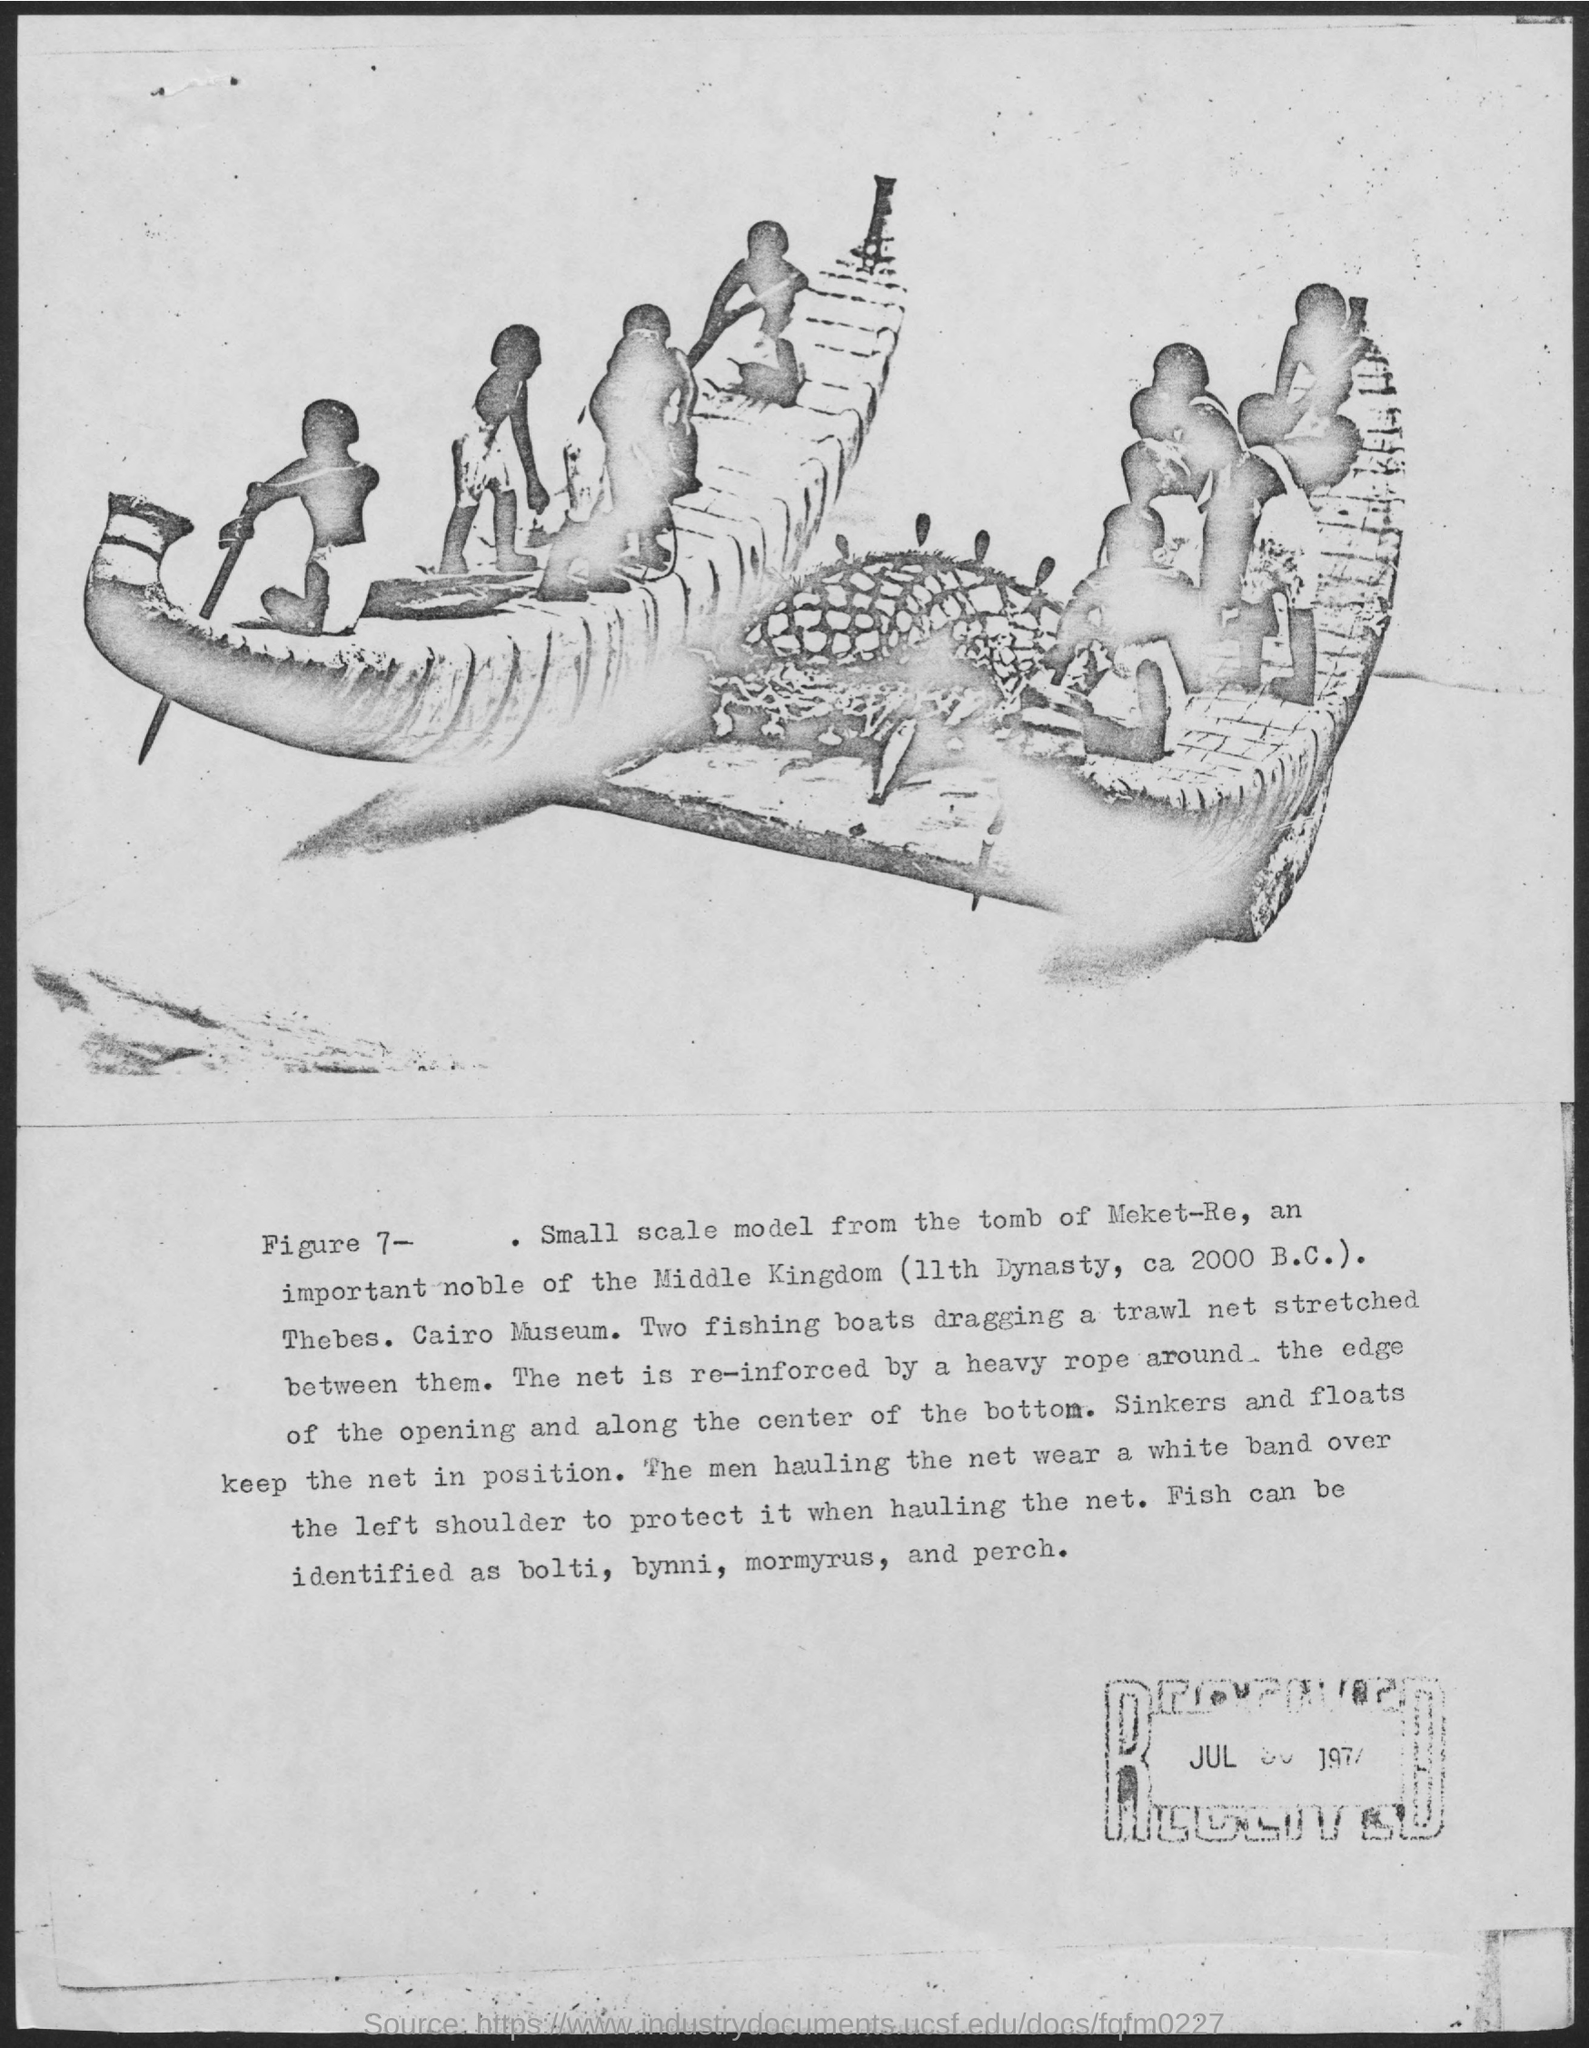Draw attention to some important aspects in this diagram. What is the number of Figures? It is 7. 